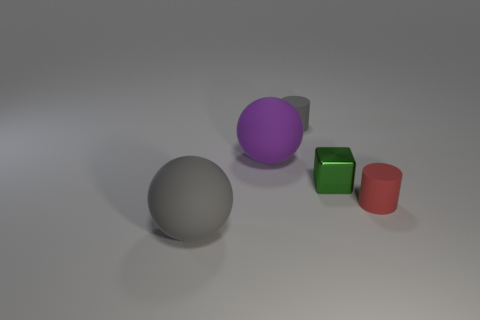Add 2 tiny gray rubber cylinders. How many objects exist? 7 Subtract all cubes. How many objects are left? 4 Subtract all gray cylinders. How many cylinders are left? 1 Subtract 0 red spheres. How many objects are left? 5 Subtract 1 spheres. How many spheres are left? 1 Subtract all red spheres. Subtract all blue cubes. How many spheres are left? 2 Subtract all gray cylinders. How many cyan spheres are left? 0 Subtract all purple rubber cubes. Subtract all red rubber cylinders. How many objects are left? 4 Add 1 small red matte cylinders. How many small red matte cylinders are left? 2 Add 2 green metallic cubes. How many green metallic cubes exist? 3 